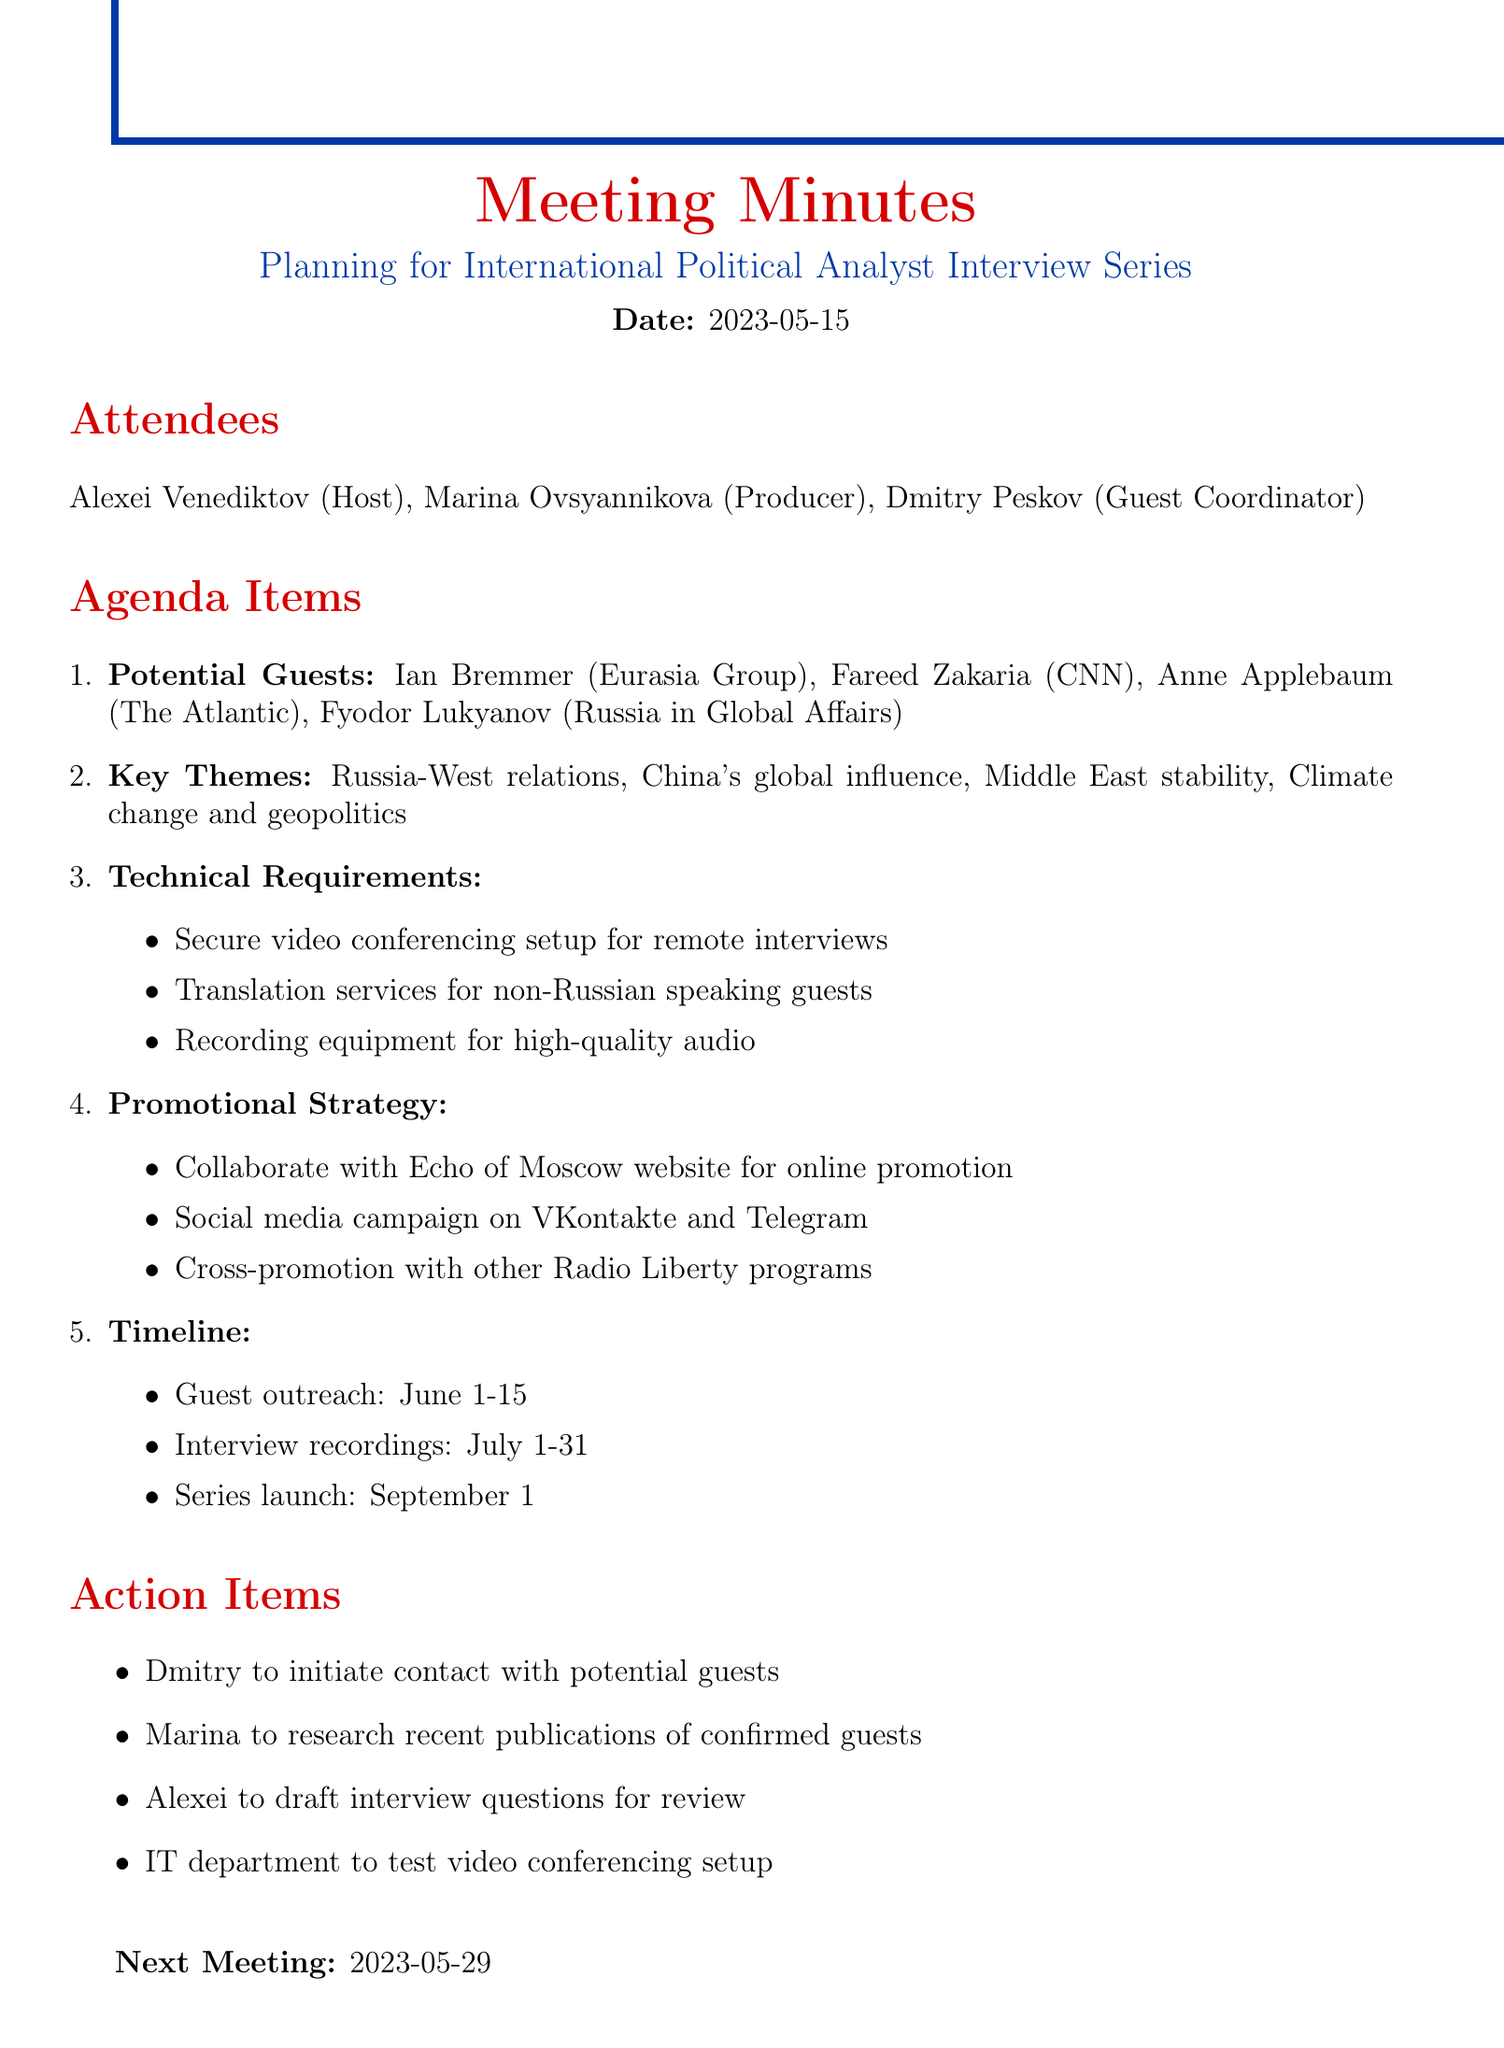What is the meeting title? The meeting title is clearly stated at the beginning of the document.
Answer: Planning for International Political Analyst Interview Series Who are the attendees? The attendees are listed under a specific section in the document.
Answer: Alexei Venediktov, Marina Ovsyannikova, Dmitry Peskov What are the potential guests mentioned? The document lists potential guests under the agenda items section.
Answer: Ian Bremmer, Fareed Zakaria, Anne Applebaum, Fyodor Lukyanov What is the timeline for guest outreach? The timeline is outlined clearly in the document under the relevant agenda item.
Answer: June 1-15 What are the key themes discussed? The key themes are listed in the agenda items, reflecting the focus of the interview series.
Answer: Russia-West relations, China's global influence, Middle East stability, Climate change and geopolitics Who is responsible for initiating contact with potential guests? Action items specify responsibilities assigned to different attendees.
Answer: Dmitry What technical requirement is needed for remote interviews? Technical requirements are listed in detail within the agenda items.
Answer: Secure video conferencing setup When is the next meeting scheduled? The next meeting date is mentioned at the end of the document.
Answer: 2023-05-29 What promotional strategy involves social media? The document outlines specific promotional strategies that utilize social media platforms.
Answer: Social media campaign on VKontakte and Telegram 